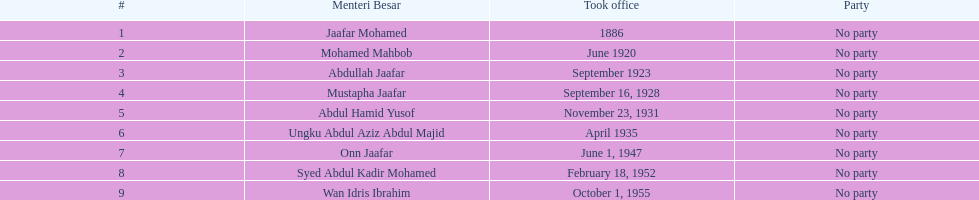Could you help me parse every detail presented in this table? {'header': ['#', 'Menteri Besar', 'Took office', 'Party'], 'rows': [['1', 'Jaafar Mohamed', '1886', 'No party'], ['2', 'Mohamed Mahbob', 'June 1920', 'No party'], ['3', 'Abdullah Jaafar', 'September 1923', 'No party'], ['4', 'Mustapha Jaafar', 'September 16, 1928', 'No party'], ['5', 'Abdul Hamid Yusof', 'November 23, 1931', 'No party'], ['6', 'Ungku Abdul Aziz Abdul Majid', 'April 1935', 'No party'], ['7', 'Onn Jaafar', 'June 1, 1947', 'No party'], ['8', 'Syed Abdul Kadir Mohamed', 'February 18, 1952', 'No party'], ['9', 'Wan Idris Ibrahim', 'October 1, 1955', 'No party']]} Who was the first to take office? Jaafar Mohamed. 